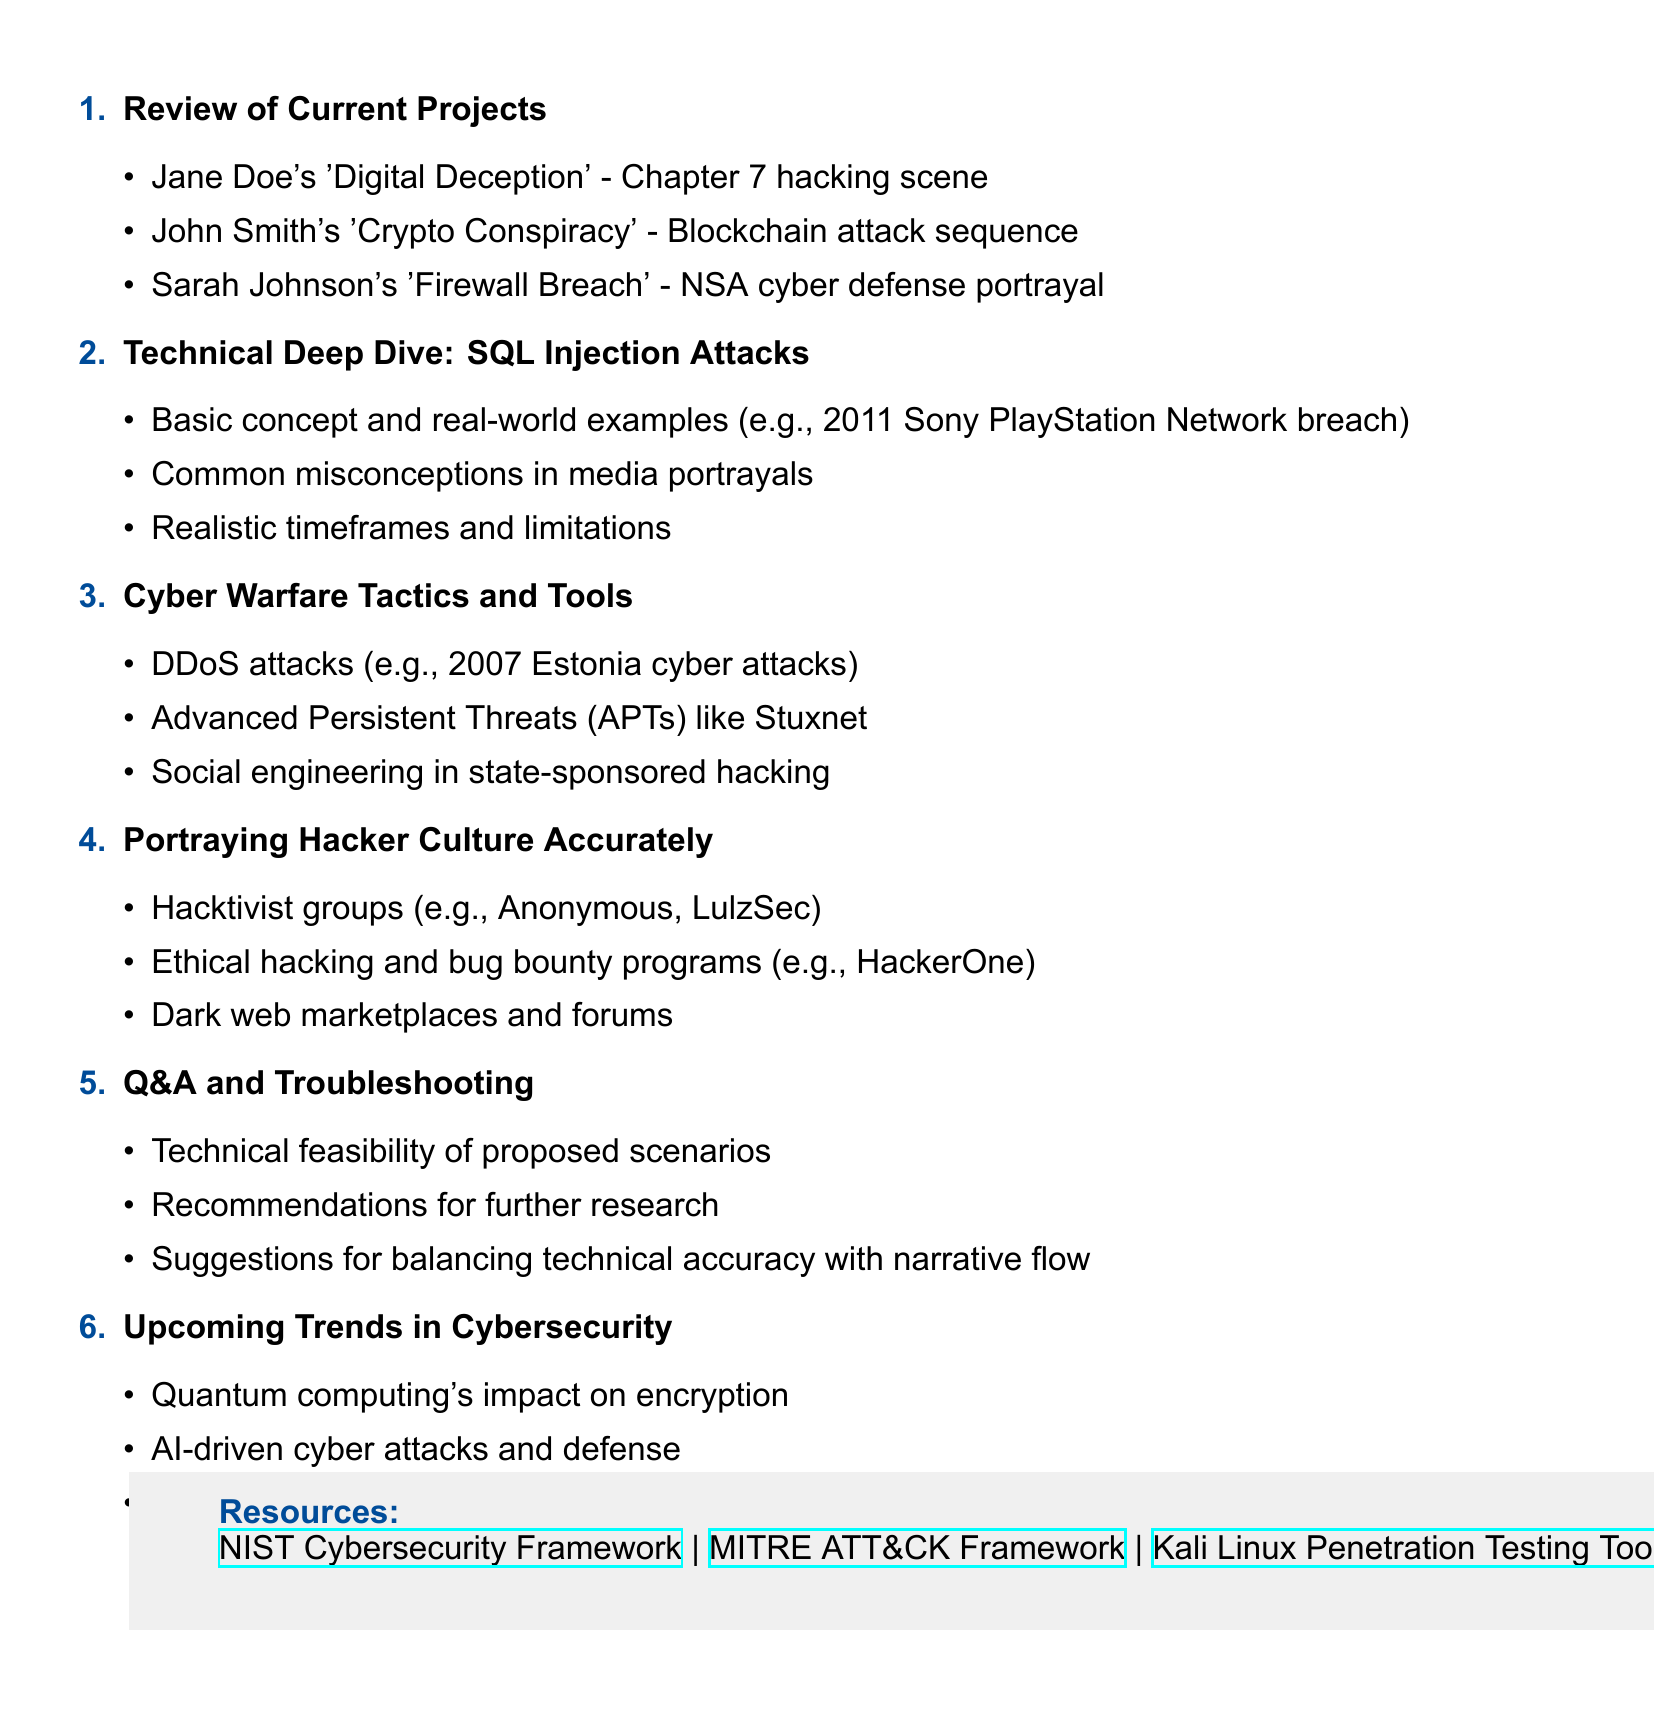What is the title of the meeting? The title is found at the beginning of the document.
Answer: Bi-weekly Author Collaboration: Hacking and Cyber Warfare in Thrillers How many objectives are listed for the meeting? The number of objectives is counted in the meeting objectives section.
Answer: 3 What is the first agenda item? The first agenda item is noted at the start of the agenda items section.
Answer: Review of Current Projects Which hacking technique is discussed in the Technical Deep Dive agenda item? The specific hacking technique can be found in the title of the corresponding agenda item.
Answer: SQL Injection Attacks What year did the Sony PlayStation Network breach occur? The year mentioned in the discussion of real-world examples under the SQL injection attacks agenda item.
Answer: 2011 What type of attacks is highlighted in the Cyber Warfare Tactics and Tools agenda item? The types of attacks can be determined by examining the subtopics listed in that agenda item.
Answer: DDoS attacks What is one of the resources provided in the document? Resources are specifically listed under the resources section.
Answer: NIST Cybersecurity Framework What is one of the upcoming trends in cybersecurity mentioned? The trends are outlined in the last agenda item, which specifically lists current cybersecurity trends.
Answer: Quantum computing's impact on encryption 